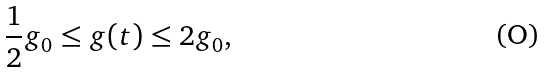<formula> <loc_0><loc_0><loc_500><loc_500>\frac { 1 } { 2 } g _ { 0 } \leq g ( t ) \leq 2 g _ { 0 } ,</formula> 